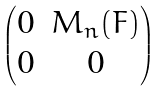<formula> <loc_0><loc_0><loc_500><loc_500>\begin{pmatrix} 0 & M _ { n } ( F ) \\ 0 & 0 \end{pmatrix}</formula> 